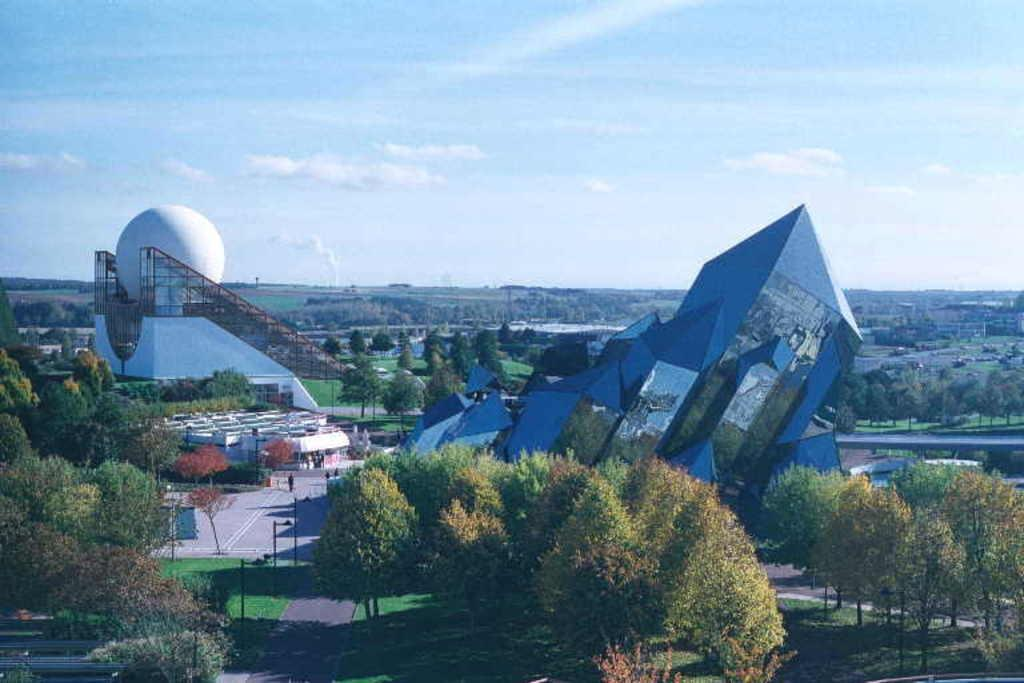What type of natural elements can be seen in the image? There are trees in the image. What type of man-made structures are present in the image? There are architectures in the image. What part of the natural environment is visible in the image? The sky is visible in the image. How many frogs can be seen sitting on the architectures in the image? There are no frogs present in the image. How long does it take for the trees to grow in the image? The image does not provide information about the growth rate of the trees. 